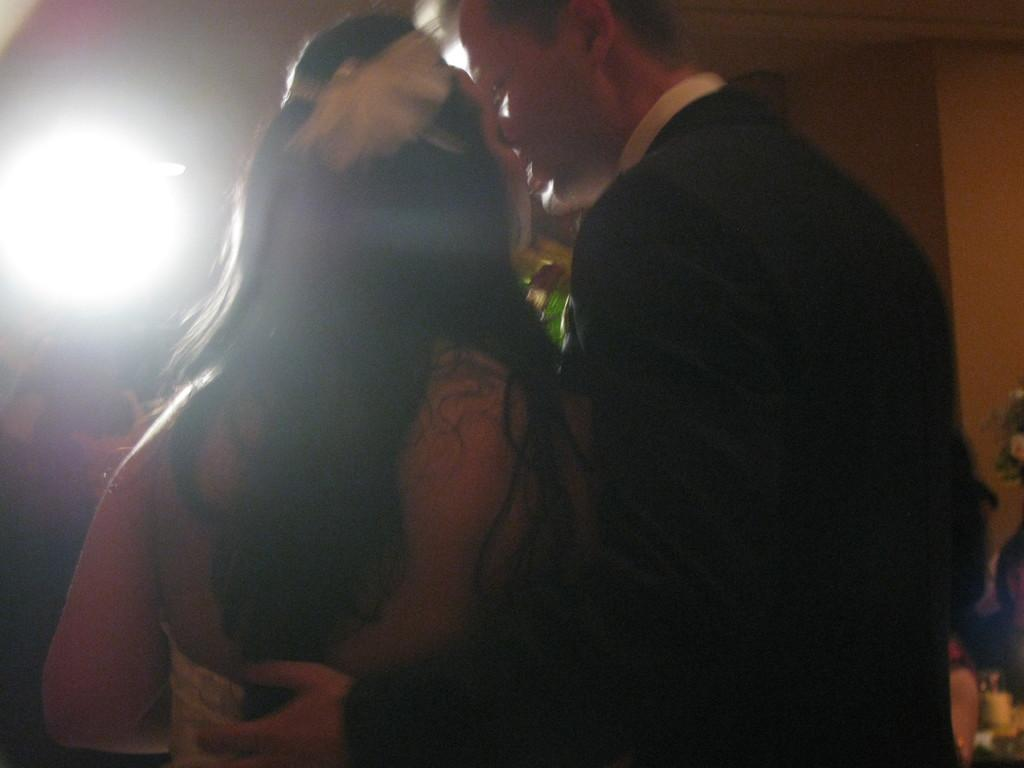How many people are in the image? There is a man and a woman in the image. What are the man and woman doing in the image? The man and woman are standing. What can be seen on the left side of the image? There is light on the left side of the image. What is on the right side of the image? There is a wall on the right side of the image. What type of body is visible on the wall in the image? There is no body visible on the wall in the image; it is a solid structure. 